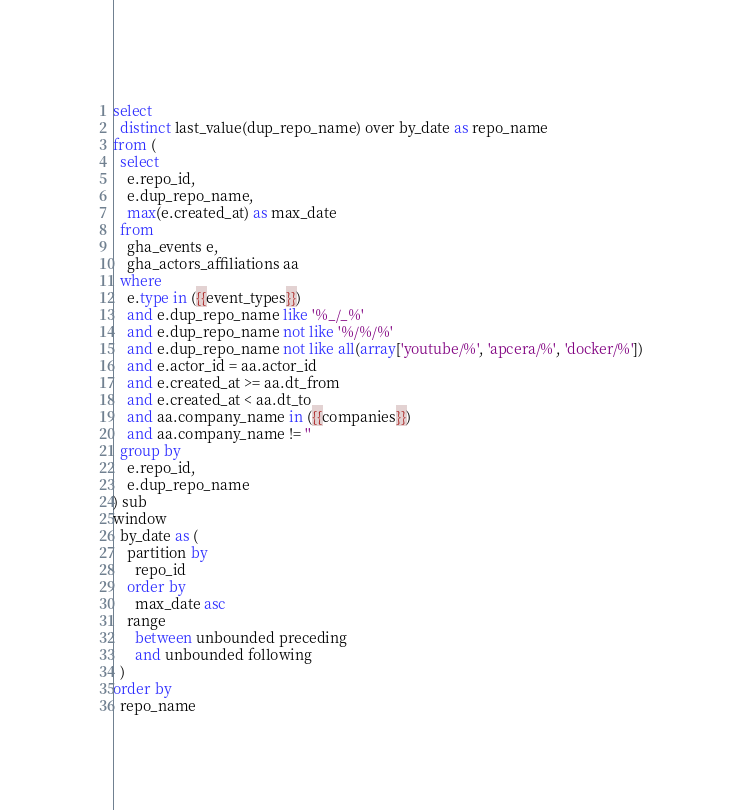<code> <loc_0><loc_0><loc_500><loc_500><_SQL_>select
  distinct last_value(dup_repo_name) over by_date as repo_name
from (
  select
    e.repo_id,
    e.dup_repo_name,
    max(e.created_at) as max_date
  from
    gha_events e,
    gha_actors_affiliations aa
  where
    e.type in ({{event_types}})
    and e.dup_repo_name like '%_/_%'
    and e.dup_repo_name not like '%/%/%'
    and e.dup_repo_name not like all(array['youtube/%', 'apcera/%', 'docker/%'])
    and e.actor_id = aa.actor_id
    and e.created_at >= aa.dt_from
    and e.created_at < aa.dt_to
    and aa.company_name in ({{companies}})
    and aa.company_name != ''
  group by
    e.repo_id,
    e.dup_repo_name
) sub
window
  by_date as (
    partition by
      repo_id
    order by
      max_date asc
    range
      between unbounded preceding
      and unbounded following
  )
order by
  repo_name
</code> 